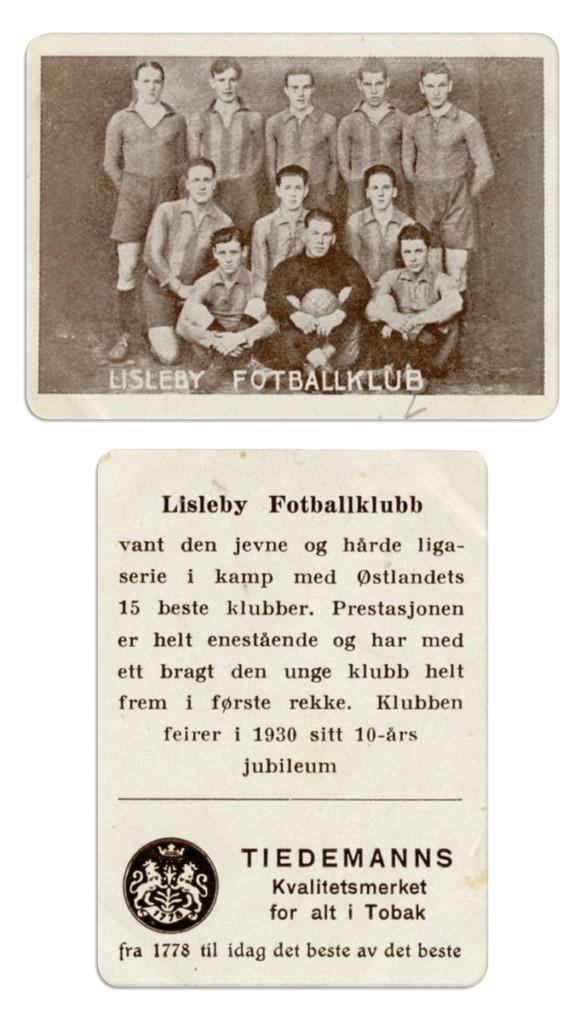Can you describe this image briefly? In this image we can see a black and white picture of two images. In one picture we can see a group of people standing. One person is holding a ball in his hand. In another picture we can see some text on it. 